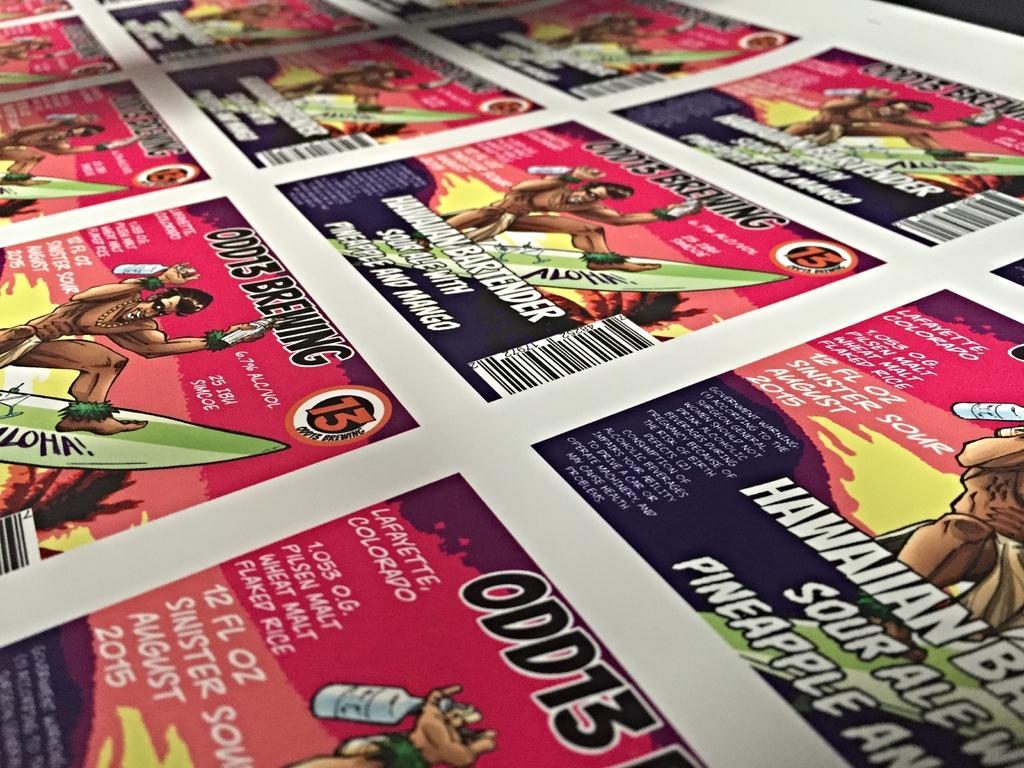Can you describe this image briefly? In this image there is a poster, on that poster there are pictures and text. 